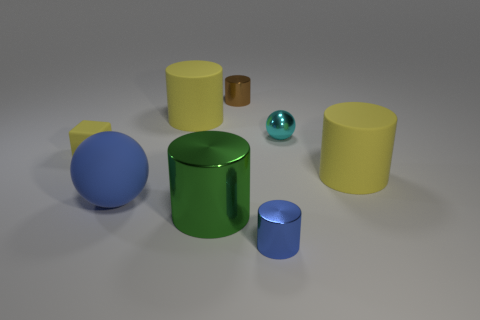Subtract all tiny metallic cylinders. How many cylinders are left? 3 Add 2 small blue cubes. How many objects exist? 10 Subtract all blue cylinders. How many cylinders are left? 4 Subtract 1 blocks. How many blocks are left? 0 Subtract all cubes. How many objects are left? 7 Subtract all purple cylinders. Subtract all cyan spheres. How many cylinders are left? 5 Subtract all red cubes. How many cyan balls are left? 1 Subtract all yellow cylinders. Subtract all rubber cylinders. How many objects are left? 4 Add 4 rubber things. How many rubber things are left? 8 Add 7 cyan matte cubes. How many cyan matte cubes exist? 7 